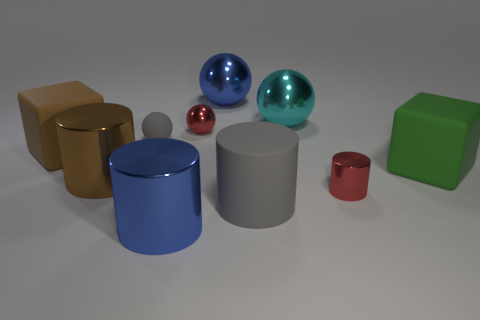What is the material of the blue cylinder?
Your answer should be compact. Metal. There is a big block that is behind the matte block that is to the right of the big blue object behind the big blue metallic cylinder; what is its material?
Provide a short and direct response. Rubber. The brown metallic thing that is the same size as the green rubber block is what shape?
Make the answer very short. Cylinder. How many objects are either large blue cylinders or blue metal things in front of the large cyan metallic thing?
Give a very brief answer. 1. Is the big sphere to the left of the big gray rubber object made of the same material as the brown object that is behind the green matte thing?
Offer a very short reply. No. What shape is the large thing that is the same color as the tiny rubber thing?
Make the answer very short. Cylinder. What number of cyan things are either metal cylinders or big metal objects?
Provide a succinct answer. 1. How big is the green matte block?
Provide a short and direct response. Large. Are there more cyan balls behind the tiny gray rubber thing than green metallic spheres?
Provide a short and direct response. Yes. What number of tiny things are behind the big brown shiny cylinder?
Give a very brief answer. 2. 